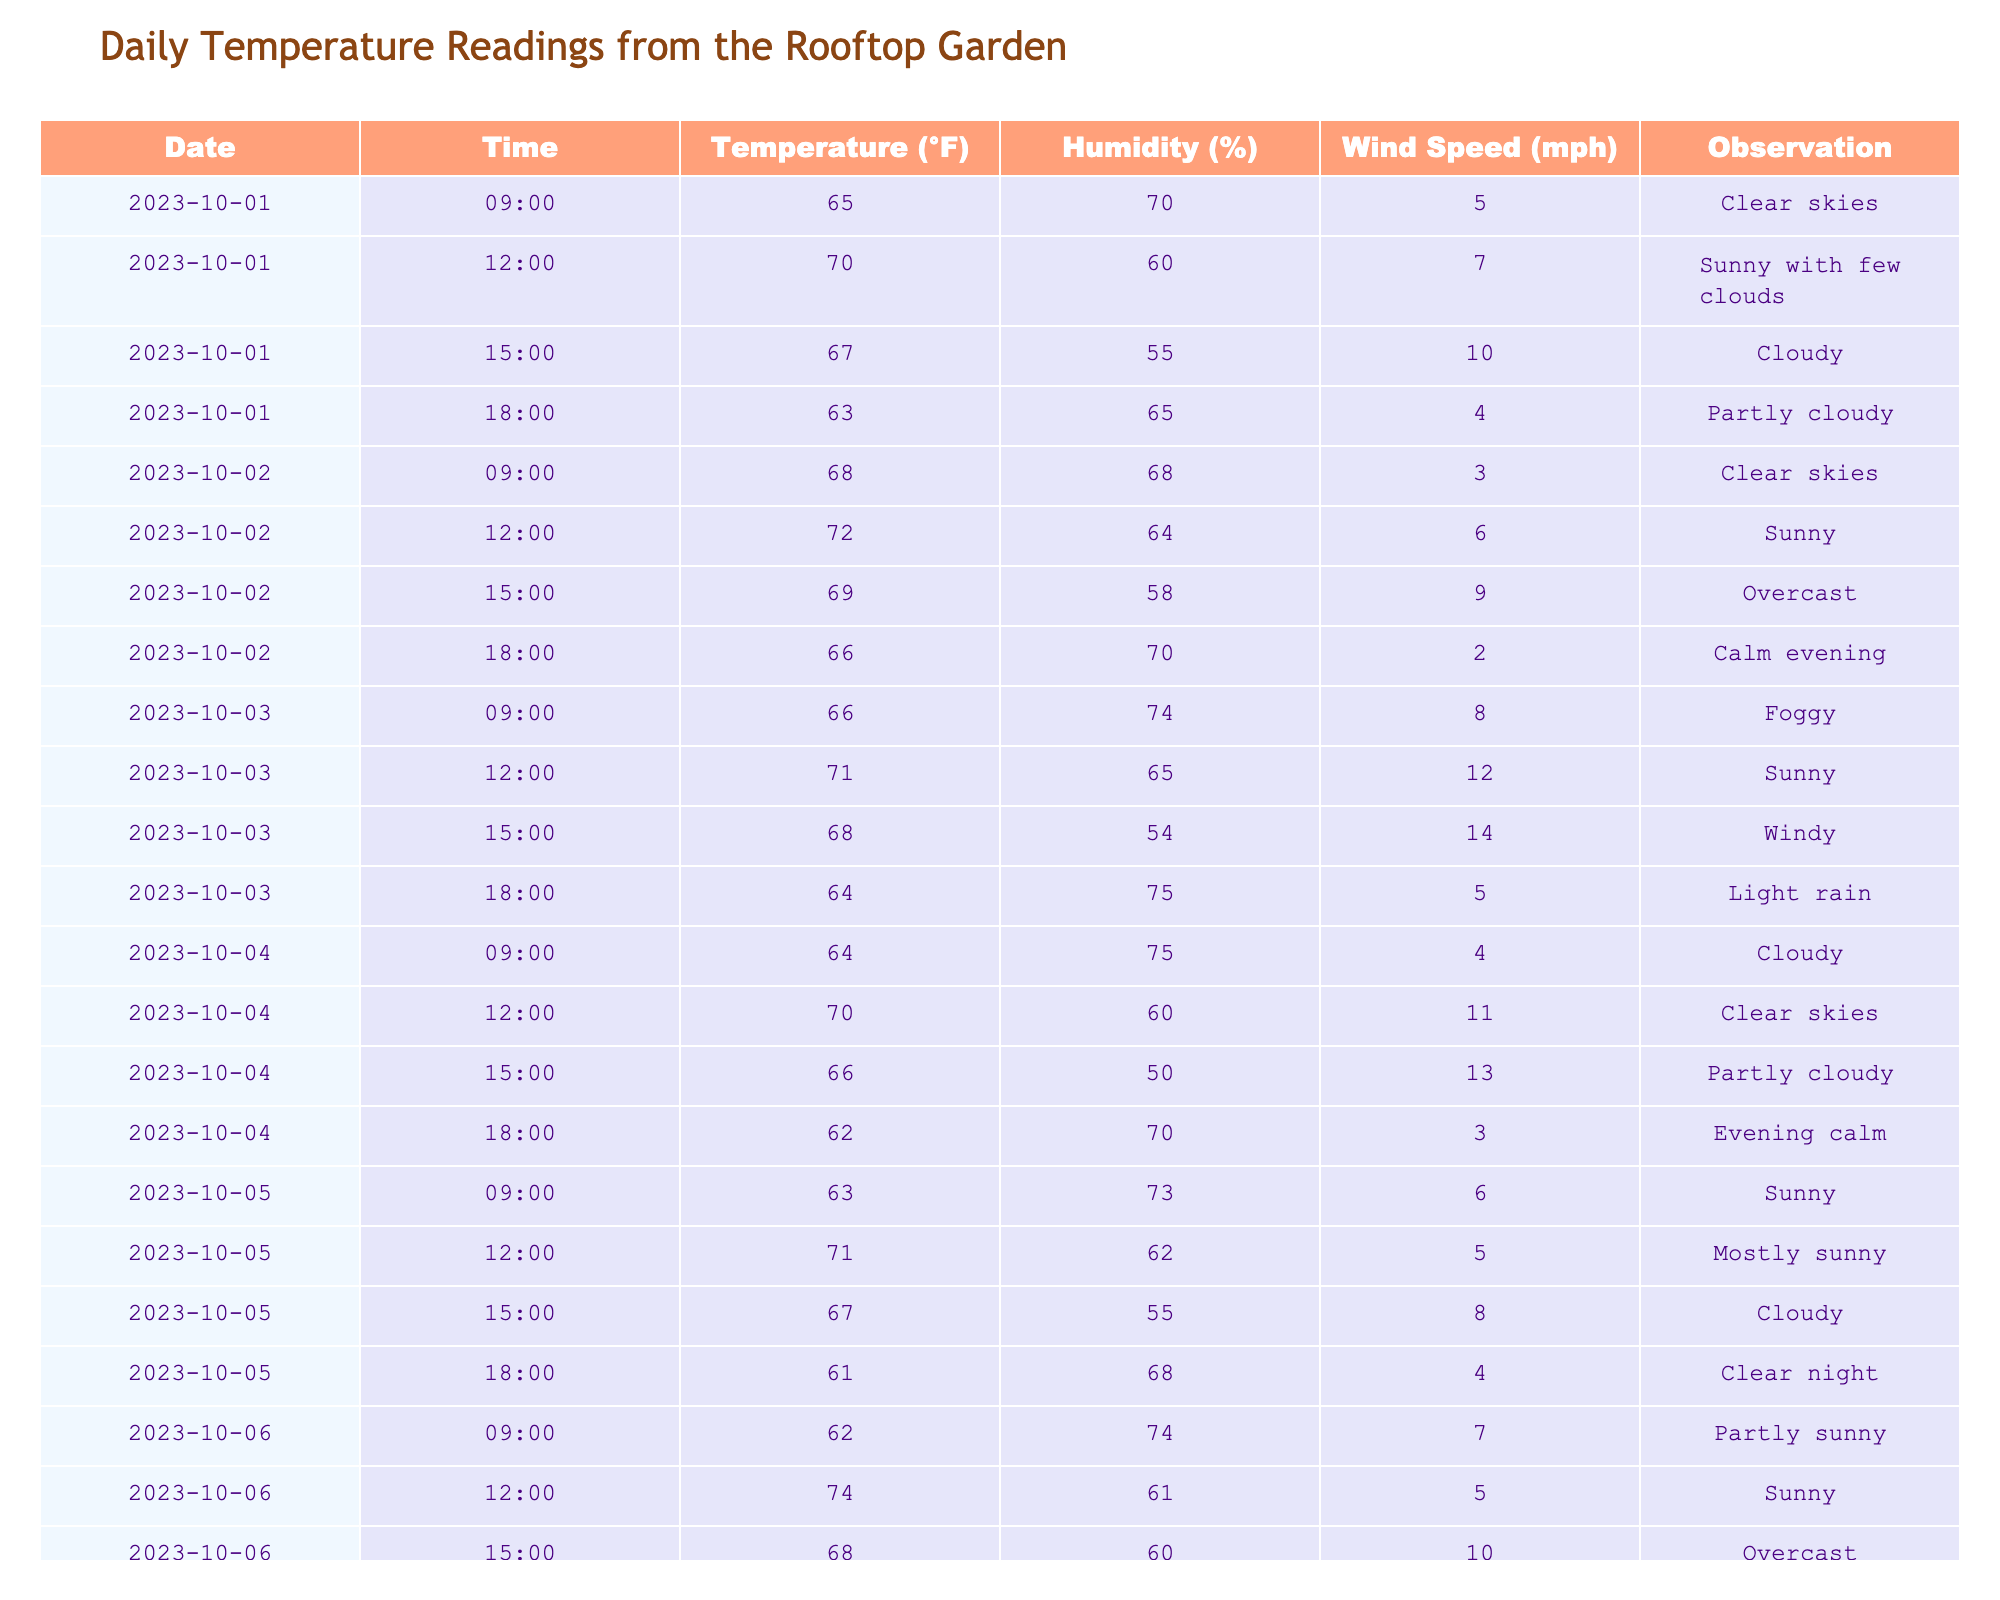What was the highest temperature recorded in the table? The highest temperature listed in the table is 74°F, which occurred on October 6 at 12:00.
Answer: 74°F What is the average humidity on October 2? The humidity readings on October 2 are 68%, 64%, 58%, and 70%. The sum is 68 + 64 + 58 + 70 = 260, and there are 4 readings, so the average is 260 / 4 = 65%.
Answer: 65% Was there any day when the wind speed exceeded 10 mph? Yes, on October 3 at 12:00, the wind speed reached 12 mph and on October 4 at 12:00, it was 11 mph.
Answer: Yes What was the temperature trend from morning to evening on October 4? On October 4, the temperatures dropped from 64°F at 09:00 to 62°F at 18:00. This shows a decrease of 2°F throughout the day.
Answer: Decreased by 2°F What was the observation during the highest temperature recorded? The highest temperature of 74°F was observed at 12:00 on October 6, and it was noted as "Sunny."
Answer: Sunny How many times did the temperature drop below 65°F throughout the table? The temperature was below 65°F at 18:00 on October 1 (63°F), 18:00 on October 3 (64°F), 18:00 on October 4 (62°F), and 18:00 on October 5 (61°F). This makes a total of 4 occurrences.
Answer: 4 times Which day had the most varied temperatures (highest difference between morning and evening)? By examining the temperature difference between the highest morning and lowest evening readings, October 3 had a maximum of 71°F at 12:00 and a minimum of 64°F at 18:00, resulting in a difference of 7°F. October 5 showed a difference of 12°F (from 63°F to 61°F), the largest observed.
Answer: October 5 What was the average temperature for all readings on October 1? The readings on October 1 are 65°F, 70°F, 67°F, and 63°F. The sum is 65 + 70 + 67 + 63 = 265, and there are 4 readings, so the average is 265 / 4 = 66.25°F.
Answer: 66.25°F On which day was the weather observed as "Calm evening"? The weather was described as "Calm evening" on October 2 at 18:00.
Answer: October 2 What were two instances when the observation noted rain? There were two instances indicating rain: October 3 at 18:00 was "Light rain." There are no other rain indications in the data provided.
Answer: Light rain on October 3 